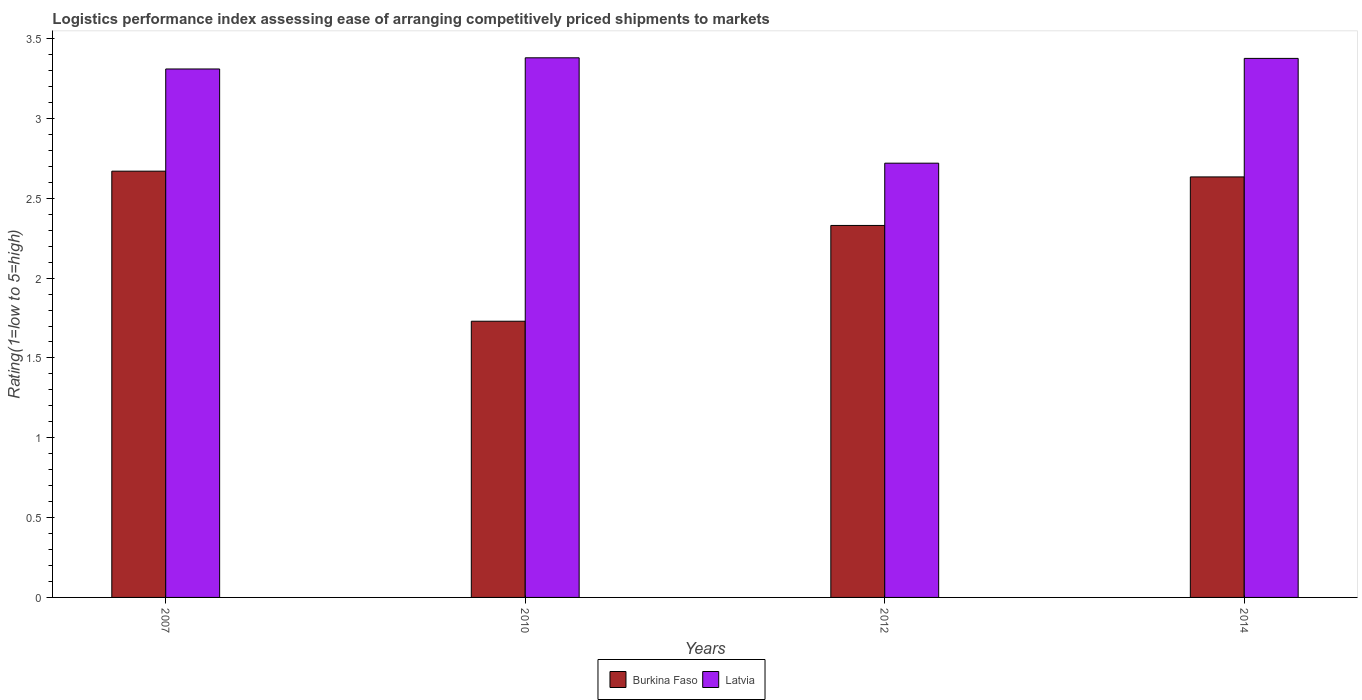How many different coloured bars are there?
Your answer should be compact. 2. Are the number of bars on each tick of the X-axis equal?
Offer a terse response. Yes. How many bars are there on the 3rd tick from the left?
Your answer should be compact. 2. How many bars are there on the 1st tick from the right?
Offer a terse response. 2. In how many cases, is the number of bars for a given year not equal to the number of legend labels?
Ensure brevity in your answer.  0. What is the Logistic performance index in Latvia in 2012?
Ensure brevity in your answer.  2.72. Across all years, what is the maximum Logistic performance index in Latvia?
Give a very brief answer. 3.38. Across all years, what is the minimum Logistic performance index in Latvia?
Give a very brief answer. 2.72. In which year was the Logistic performance index in Latvia maximum?
Offer a terse response. 2010. What is the total Logistic performance index in Burkina Faso in the graph?
Provide a succinct answer. 9.36. What is the difference between the Logistic performance index in Latvia in 2010 and that in 2014?
Give a very brief answer. 0. What is the difference between the Logistic performance index in Burkina Faso in 2007 and the Logistic performance index in Latvia in 2012?
Provide a succinct answer. -0.05. What is the average Logistic performance index in Burkina Faso per year?
Provide a short and direct response. 2.34. In the year 2007, what is the difference between the Logistic performance index in Burkina Faso and Logistic performance index in Latvia?
Provide a succinct answer. -0.64. What is the ratio of the Logistic performance index in Burkina Faso in 2007 to that in 2012?
Your answer should be compact. 1.15. Is the Logistic performance index in Latvia in 2007 less than that in 2010?
Your response must be concise. Yes. Is the difference between the Logistic performance index in Burkina Faso in 2007 and 2010 greater than the difference between the Logistic performance index in Latvia in 2007 and 2010?
Your response must be concise. Yes. What is the difference between the highest and the second highest Logistic performance index in Burkina Faso?
Give a very brief answer. 0.04. What is the difference between the highest and the lowest Logistic performance index in Latvia?
Your answer should be compact. 0.66. What does the 1st bar from the left in 2010 represents?
Offer a very short reply. Burkina Faso. What does the 2nd bar from the right in 2010 represents?
Keep it short and to the point. Burkina Faso. How many bars are there?
Provide a succinct answer. 8. How many years are there in the graph?
Give a very brief answer. 4. What is the difference between two consecutive major ticks on the Y-axis?
Offer a terse response. 0.5. Are the values on the major ticks of Y-axis written in scientific E-notation?
Your answer should be compact. No. What is the title of the graph?
Your answer should be compact. Logistics performance index assessing ease of arranging competitively priced shipments to markets. What is the label or title of the Y-axis?
Ensure brevity in your answer.  Rating(1=low to 5=high). What is the Rating(1=low to 5=high) in Burkina Faso in 2007?
Provide a succinct answer. 2.67. What is the Rating(1=low to 5=high) in Latvia in 2007?
Your answer should be compact. 3.31. What is the Rating(1=low to 5=high) of Burkina Faso in 2010?
Offer a terse response. 1.73. What is the Rating(1=low to 5=high) of Latvia in 2010?
Provide a short and direct response. 3.38. What is the Rating(1=low to 5=high) of Burkina Faso in 2012?
Give a very brief answer. 2.33. What is the Rating(1=low to 5=high) in Latvia in 2012?
Provide a succinct answer. 2.72. What is the Rating(1=low to 5=high) in Burkina Faso in 2014?
Offer a very short reply. 2.63. What is the Rating(1=low to 5=high) in Latvia in 2014?
Provide a succinct answer. 3.38. Across all years, what is the maximum Rating(1=low to 5=high) in Burkina Faso?
Your answer should be very brief. 2.67. Across all years, what is the maximum Rating(1=low to 5=high) of Latvia?
Your answer should be compact. 3.38. Across all years, what is the minimum Rating(1=low to 5=high) in Burkina Faso?
Offer a terse response. 1.73. Across all years, what is the minimum Rating(1=low to 5=high) in Latvia?
Provide a succinct answer. 2.72. What is the total Rating(1=low to 5=high) in Burkina Faso in the graph?
Give a very brief answer. 9.36. What is the total Rating(1=low to 5=high) in Latvia in the graph?
Keep it short and to the point. 12.79. What is the difference between the Rating(1=low to 5=high) in Latvia in 2007 and that in 2010?
Keep it short and to the point. -0.07. What is the difference between the Rating(1=low to 5=high) of Burkina Faso in 2007 and that in 2012?
Your answer should be very brief. 0.34. What is the difference between the Rating(1=low to 5=high) in Latvia in 2007 and that in 2012?
Your answer should be very brief. 0.59. What is the difference between the Rating(1=low to 5=high) of Burkina Faso in 2007 and that in 2014?
Offer a terse response. 0.04. What is the difference between the Rating(1=low to 5=high) in Latvia in 2007 and that in 2014?
Your response must be concise. -0.07. What is the difference between the Rating(1=low to 5=high) of Burkina Faso in 2010 and that in 2012?
Your answer should be very brief. -0.6. What is the difference between the Rating(1=low to 5=high) in Latvia in 2010 and that in 2012?
Give a very brief answer. 0.66. What is the difference between the Rating(1=low to 5=high) in Burkina Faso in 2010 and that in 2014?
Make the answer very short. -0.9. What is the difference between the Rating(1=low to 5=high) of Latvia in 2010 and that in 2014?
Offer a terse response. 0. What is the difference between the Rating(1=low to 5=high) of Burkina Faso in 2012 and that in 2014?
Your response must be concise. -0.3. What is the difference between the Rating(1=low to 5=high) in Latvia in 2012 and that in 2014?
Provide a short and direct response. -0.66. What is the difference between the Rating(1=low to 5=high) in Burkina Faso in 2007 and the Rating(1=low to 5=high) in Latvia in 2010?
Offer a very short reply. -0.71. What is the difference between the Rating(1=low to 5=high) in Burkina Faso in 2007 and the Rating(1=low to 5=high) in Latvia in 2012?
Provide a short and direct response. -0.05. What is the difference between the Rating(1=low to 5=high) in Burkina Faso in 2007 and the Rating(1=low to 5=high) in Latvia in 2014?
Provide a short and direct response. -0.71. What is the difference between the Rating(1=low to 5=high) in Burkina Faso in 2010 and the Rating(1=low to 5=high) in Latvia in 2012?
Your answer should be very brief. -0.99. What is the difference between the Rating(1=low to 5=high) of Burkina Faso in 2010 and the Rating(1=low to 5=high) of Latvia in 2014?
Your answer should be very brief. -1.65. What is the difference between the Rating(1=low to 5=high) in Burkina Faso in 2012 and the Rating(1=low to 5=high) in Latvia in 2014?
Offer a very short reply. -1.05. What is the average Rating(1=low to 5=high) in Burkina Faso per year?
Your answer should be very brief. 2.34. What is the average Rating(1=low to 5=high) of Latvia per year?
Offer a terse response. 3.2. In the year 2007, what is the difference between the Rating(1=low to 5=high) in Burkina Faso and Rating(1=low to 5=high) in Latvia?
Provide a succinct answer. -0.64. In the year 2010, what is the difference between the Rating(1=low to 5=high) of Burkina Faso and Rating(1=low to 5=high) of Latvia?
Give a very brief answer. -1.65. In the year 2012, what is the difference between the Rating(1=low to 5=high) of Burkina Faso and Rating(1=low to 5=high) of Latvia?
Your answer should be very brief. -0.39. In the year 2014, what is the difference between the Rating(1=low to 5=high) in Burkina Faso and Rating(1=low to 5=high) in Latvia?
Provide a succinct answer. -0.74. What is the ratio of the Rating(1=low to 5=high) of Burkina Faso in 2007 to that in 2010?
Make the answer very short. 1.54. What is the ratio of the Rating(1=low to 5=high) of Latvia in 2007 to that in 2010?
Keep it short and to the point. 0.98. What is the ratio of the Rating(1=low to 5=high) in Burkina Faso in 2007 to that in 2012?
Provide a succinct answer. 1.15. What is the ratio of the Rating(1=low to 5=high) in Latvia in 2007 to that in 2012?
Ensure brevity in your answer.  1.22. What is the ratio of the Rating(1=low to 5=high) of Burkina Faso in 2007 to that in 2014?
Offer a very short reply. 1.01. What is the ratio of the Rating(1=low to 5=high) in Latvia in 2007 to that in 2014?
Keep it short and to the point. 0.98. What is the ratio of the Rating(1=low to 5=high) in Burkina Faso in 2010 to that in 2012?
Provide a succinct answer. 0.74. What is the ratio of the Rating(1=low to 5=high) of Latvia in 2010 to that in 2012?
Keep it short and to the point. 1.24. What is the ratio of the Rating(1=low to 5=high) of Burkina Faso in 2010 to that in 2014?
Make the answer very short. 0.66. What is the ratio of the Rating(1=low to 5=high) of Latvia in 2010 to that in 2014?
Provide a short and direct response. 1. What is the ratio of the Rating(1=low to 5=high) of Burkina Faso in 2012 to that in 2014?
Provide a succinct answer. 0.88. What is the ratio of the Rating(1=low to 5=high) of Latvia in 2012 to that in 2014?
Your response must be concise. 0.81. What is the difference between the highest and the second highest Rating(1=low to 5=high) in Burkina Faso?
Offer a very short reply. 0.04. What is the difference between the highest and the second highest Rating(1=low to 5=high) of Latvia?
Provide a short and direct response. 0. What is the difference between the highest and the lowest Rating(1=low to 5=high) in Latvia?
Offer a terse response. 0.66. 